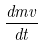Convert formula to latex. <formula><loc_0><loc_0><loc_500><loc_500>\frac { d m v } { d t }</formula> 